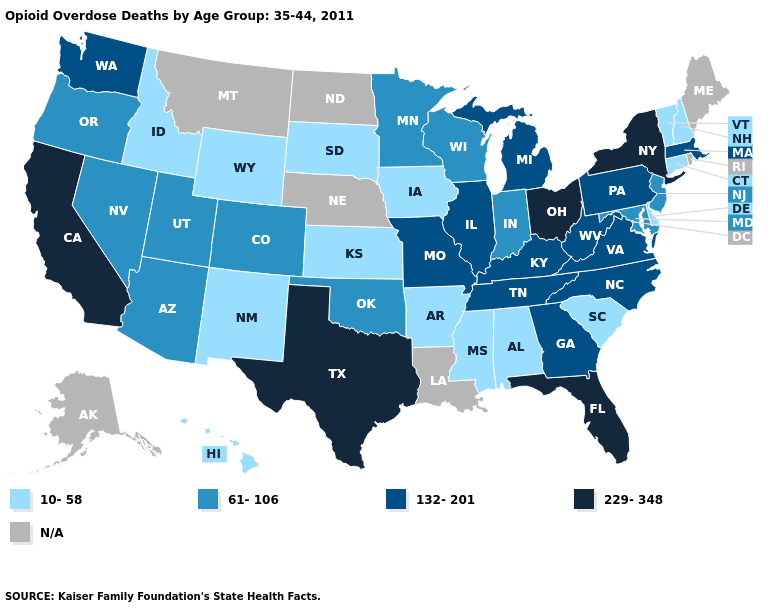Does the first symbol in the legend represent the smallest category?
Quick response, please. Yes. Is the legend a continuous bar?
Concise answer only. No. How many symbols are there in the legend?
Concise answer only. 5. What is the highest value in states that border Indiana?
Quick response, please. 229-348. Which states have the highest value in the USA?
Write a very short answer. California, Florida, New York, Ohio, Texas. What is the highest value in the MidWest ?
Short answer required. 229-348. Name the states that have a value in the range N/A?
Answer briefly. Alaska, Louisiana, Maine, Montana, Nebraska, North Dakota, Rhode Island. Does Kansas have the lowest value in the USA?
Keep it brief. Yes. Does the map have missing data?
Short answer required. Yes. Which states have the lowest value in the South?
Quick response, please. Alabama, Arkansas, Delaware, Mississippi, South Carolina. Does the first symbol in the legend represent the smallest category?
Short answer required. Yes. Which states have the lowest value in the South?
Concise answer only. Alabama, Arkansas, Delaware, Mississippi, South Carolina. What is the lowest value in the USA?
Concise answer only. 10-58. Does Minnesota have the lowest value in the USA?
Short answer required. No. 